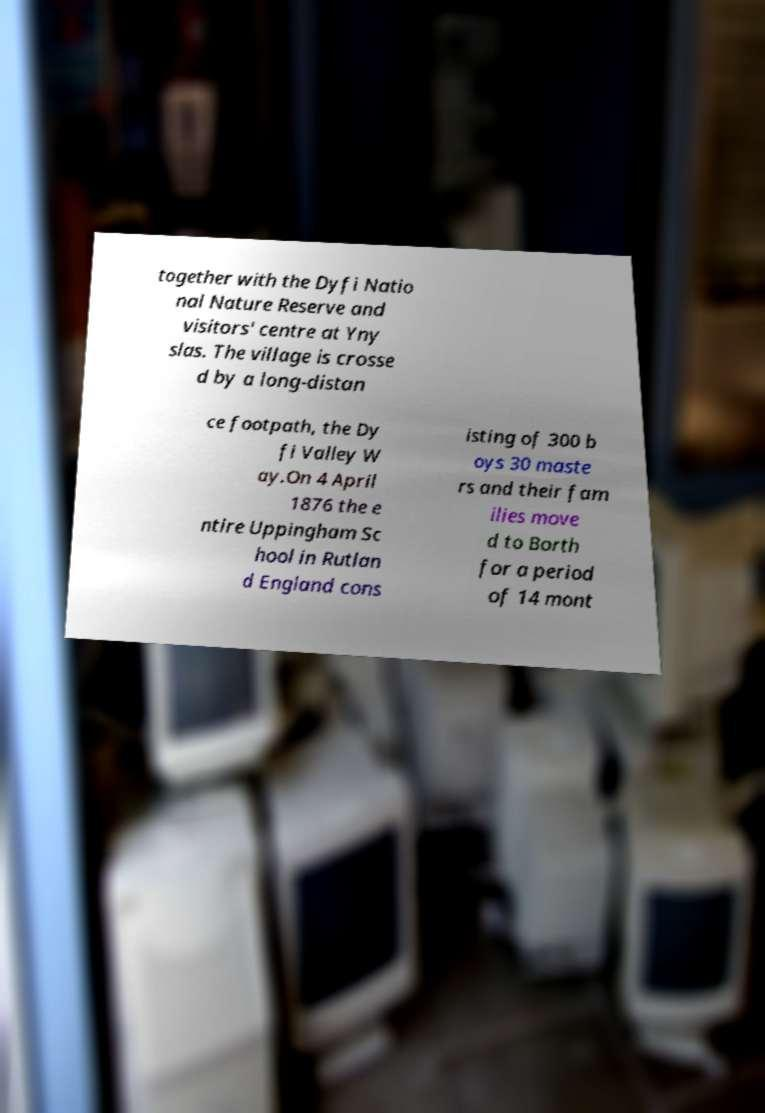What messages or text are displayed in this image? I need them in a readable, typed format. together with the Dyfi Natio nal Nature Reserve and visitors' centre at Yny slas. The village is crosse d by a long-distan ce footpath, the Dy fi Valley W ay.On 4 April 1876 the e ntire Uppingham Sc hool in Rutlan d England cons isting of 300 b oys 30 maste rs and their fam ilies move d to Borth for a period of 14 mont 